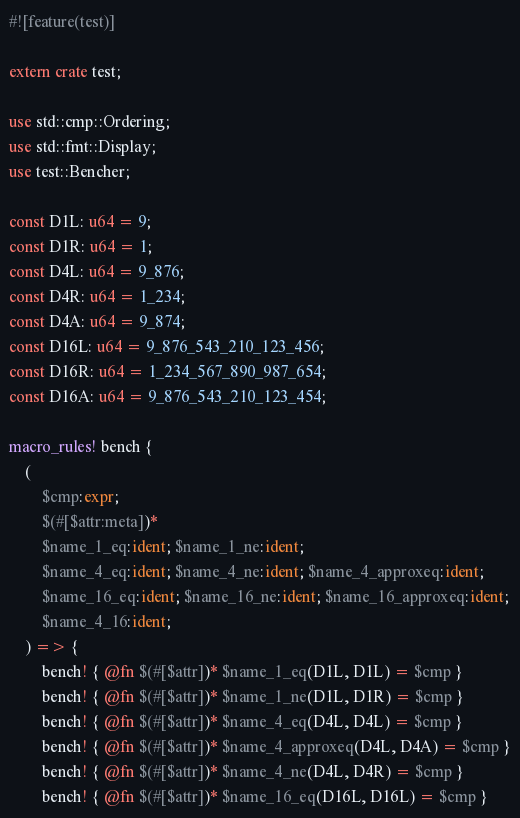Convert code to text. <code><loc_0><loc_0><loc_500><loc_500><_Rust_>#![feature(test)]

extern crate test;

use std::cmp::Ordering;
use std::fmt::Display;
use test::Bencher;

const D1L: u64 = 9;
const D1R: u64 = 1;
const D4L: u64 = 9_876;
const D4R: u64 = 1_234;
const D4A: u64 = 9_874;
const D16L: u64 = 9_876_543_210_123_456;
const D16R: u64 = 1_234_567_890_987_654;
const D16A: u64 = 9_876_543_210_123_454;

macro_rules! bench {
    (
        $cmp:expr;
        $(#[$attr:meta])*
        $name_1_eq:ident; $name_1_ne:ident;
        $name_4_eq:ident; $name_4_ne:ident; $name_4_approxeq:ident;
        $name_16_eq:ident; $name_16_ne:ident; $name_16_approxeq:ident;
        $name_4_16:ident;
    ) => {
        bench! { @fn $(#[$attr])* $name_1_eq(D1L, D1L) = $cmp }
        bench! { @fn $(#[$attr])* $name_1_ne(D1L, D1R) = $cmp }
        bench! { @fn $(#[$attr])* $name_4_eq(D4L, D4L) = $cmp }
        bench! { @fn $(#[$attr])* $name_4_approxeq(D4L, D4A) = $cmp }
        bench! { @fn $(#[$attr])* $name_4_ne(D4L, D4R) = $cmp }
        bench! { @fn $(#[$attr])* $name_16_eq(D16L, D16L) = $cmp }</code> 